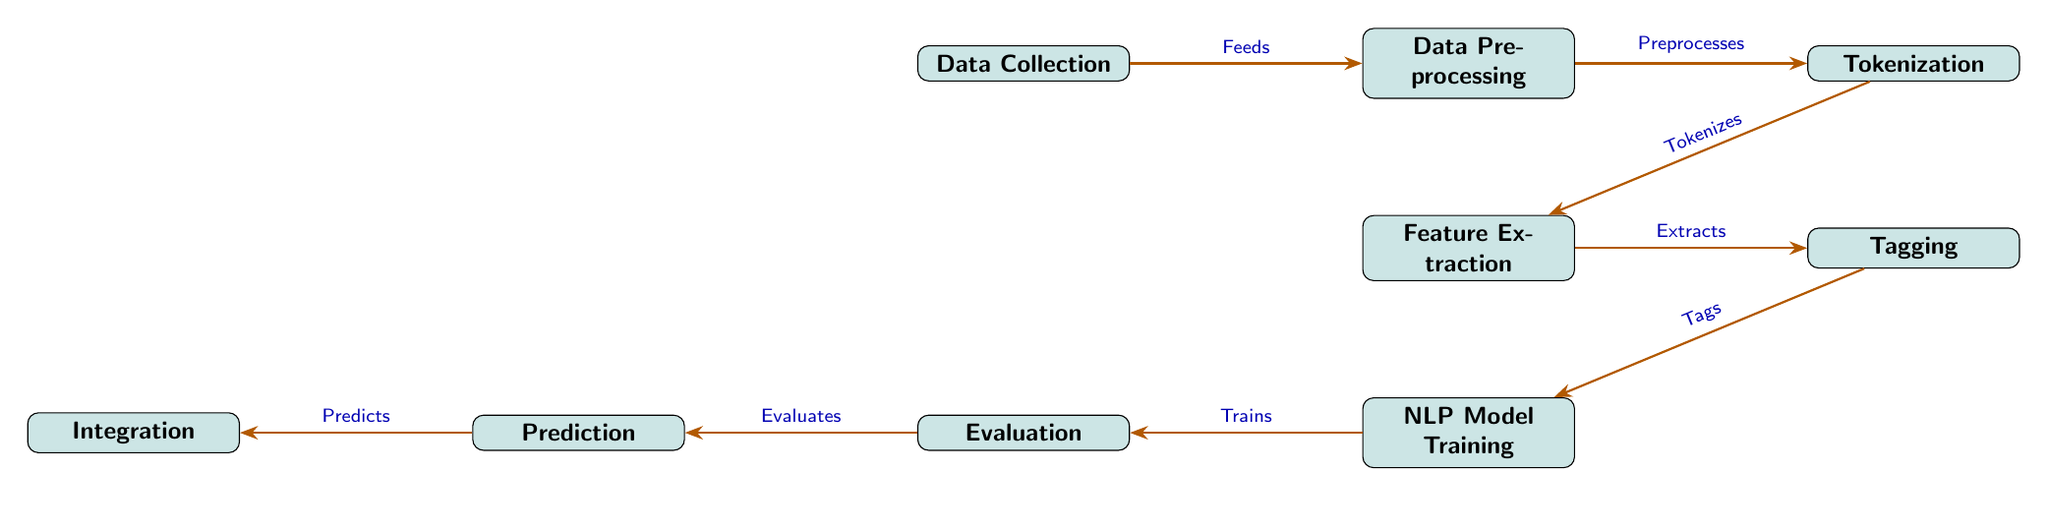What is the first step in the pipeline? The first step is Data Collection, which involves gathering digital content and metadata from library databases.
Answer: Data Collection What does the Data Preprocessing node do? The Data Preprocessing node cleans and normalizes text data, preparing it for further processing.
Answer: Cleaning and normalizing text data How many nodes are present in the diagram? The diagram contains nine nodes, each representing a step in the Natural Language Processing pipeline for metadata tagging.
Answer: Nine What action occurs between Tokenization and Feature Extraction? The Tokenization step splits the text into individual words or phrases, which is then followed by Feature Extraction.
Answer: Tokenizes What is the last action in the diagram before Integration? Before Integration, the model makes Predictions based on the training and evaluation steps that precede it.
Answer: Predicts Which node is responsible for assigning metadata tags? The Tagging node is responsible for assigning metadata tags to the text features extracted in the previous step.
Answer: Tagging What is the main goal of the Evaluation node? The Evaluation node's main goal is to assess the model's accuracy and performance after training.
Answer: Assessing the model's accuracy and performance What is the relationship between Feature Extraction and NLP Model Training? Feature Extraction extracts key traits from the text data, which is then used to train machine learning models in the NLP Model Training step.
Answer: Extracts How is the output from the Prediction node utilized? The output from the Prediction node is integrated into library systems, making tagged content usable.
Answer: Incorporating tagged content into library systems 